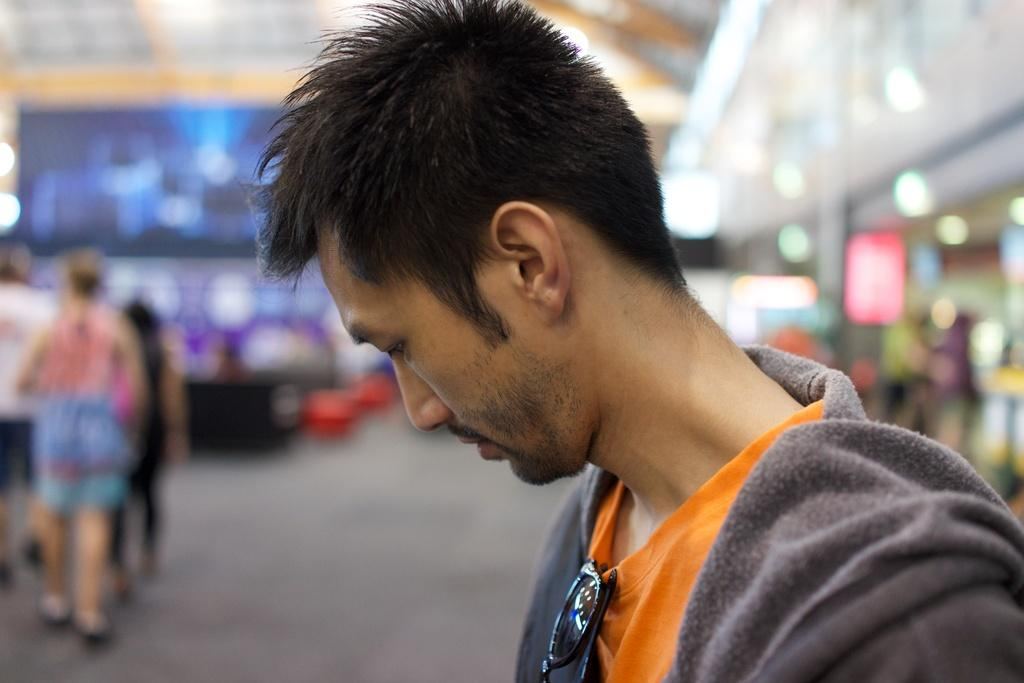What is the main subject of the image? The main subject of the image is a group of people. What can be seen in the middle of the image? There are spectacles in the middle of the image. Can you describe the man in the middle of the image? The man in the middle of the image is wearing a sweater. What can be seen in the background of the image? There are lights visible in the background of the image. What type of story is being told by the people in the image? There is no indication of a story being told in the image; it simply shows a group of people with spectacles and a man wearing a sweater. Can you see a nest in the image? There is no nest present in the image. 